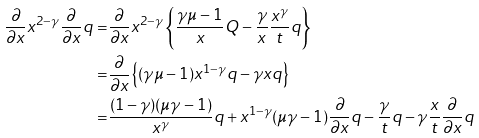Convert formula to latex. <formula><loc_0><loc_0><loc_500><loc_500>\frac { \partial } { \partial x } x ^ { 2 - \gamma } \frac { \partial } { \partial x } q = & \frac { \partial } { \partial x } x ^ { 2 - \gamma } \left \{ \frac { \gamma \mu - 1 } { x } Q - \frac { \gamma } { x } \frac { x ^ { \gamma } } { t } q \right \} \\ = & \frac { \partial } { \partial x } \left \{ ( \gamma \mu - 1 ) x ^ { 1 - \gamma } q - \gamma x q \right \} \\ = & \frac { ( 1 - \gamma ) ( \mu \gamma - 1 ) } { x ^ { \gamma } } q + x ^ { 1 - \gamma } ( \mu \gamma - 1 ) \frac { \partial } { \partial x } q - \frac { \gamma } { t } q - \gamma \frac { x } { t } \frac { \partial } { \partial x } q</formula> 